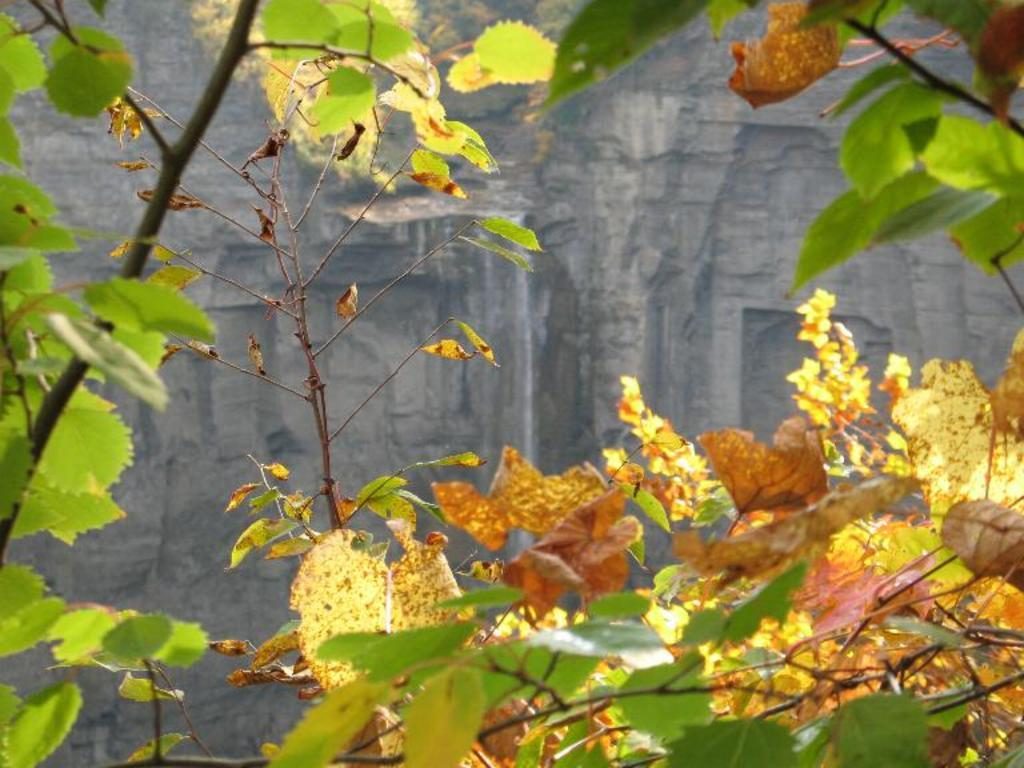What type of living organisms can be seen in the image? Plants and leaves are visible in the image. Can you describe any specific features of the plants? The plants have leaves, which are also visible in the image. What can be seen in the background of the image? There is a big rock in the background of the image. What type of advertisement can be seen on the car in the image? There is no car present in the image, so there cannot be an advertisement on a car. 